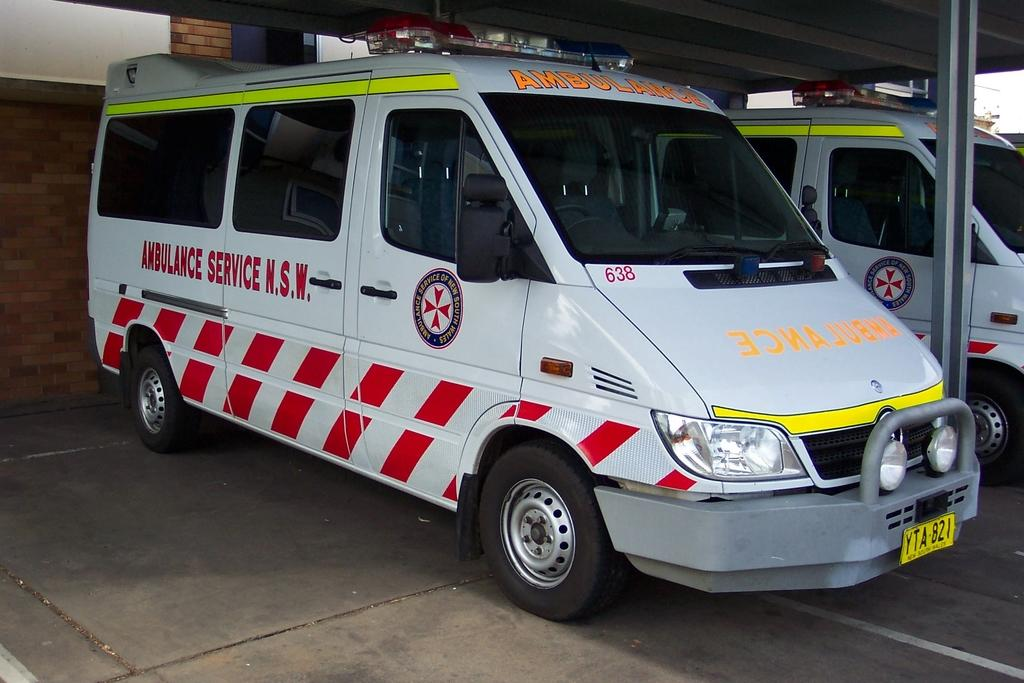<image>
Provide a brief description of the given image. Two ambulance service N.S.W. vehicles are parked in a garage. 